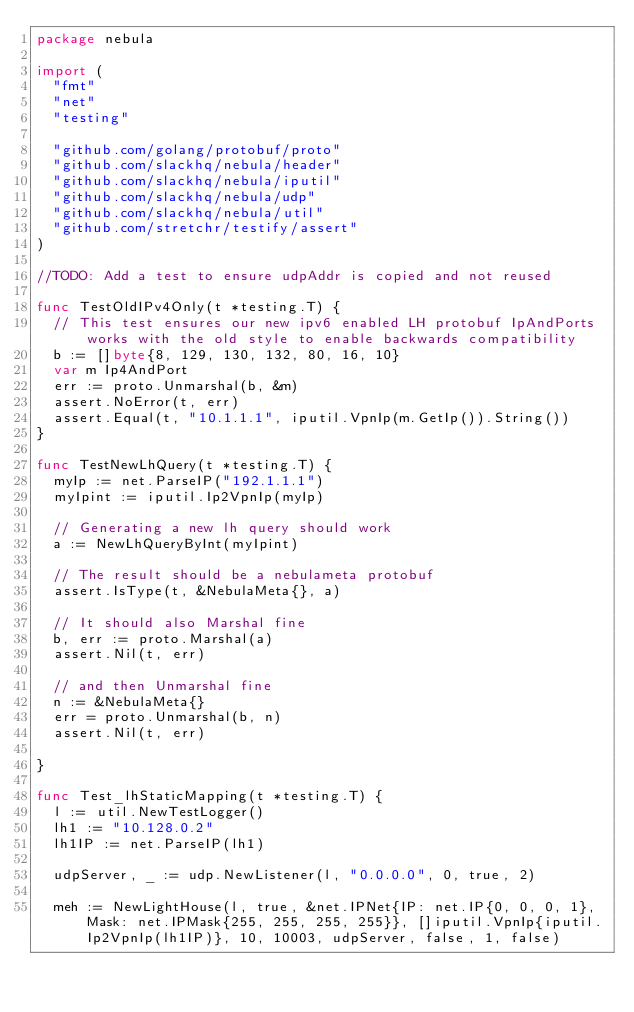Convert code to text. <code><loc_0><loc_0><loc_500><loc_500><_Go_>package nebula

import (
	"fmt"
	"net"
	"testing"

	"github.com/golang/protobuf/proto"
	"github.com/slackhq/nebula/header"
	"github.com/slackhq/nebula/iputil"
	"github.com/slackhq/nebula/udp"
	"github.com/slackhq/nebula/util"
	"github.com/stretchr/testify/assert"
)

//TODO: Add a test to ensure udpAddr is copied and not reused

func TestOldIPv4Only(t *testing.T) {
	// This test ensures our new ipv6 enabled LH protobuf IpAndPorts works with the old style to enable backwards compatibility
	b := []byte{8, 129, 130, 132, 80, 16, 10}
	var m Ip4AndPort
	err := proto.Unmarshal(b, &m)
	assert.NoError(t, err)
	assert.Equal(t, "10.1.1.1", iputil.VpnIp(m.GetIp()).String())
}

func TestNewLhQuery(t *testing.T) {
	myIp := net.ParseIP("192.1.1.1")
	myIpint := iputil.Ip2VpnIp(myIp)

	// Generating a new lh query should work
	a := NewLhQueryByInt(myIpint)

	// The result should be a nebulameta protobuf
	assert.IsType(t, &NebulaMeta{}, a)

	// It should also Marshal fine
	b, err := proto.Marshal(a)
	assert.Nil(t, err)

	// and then Unmarshal fine
	n := &NebulaMeta{}
	err = proto.Unmarshal(b, n)
	assert.Nil(t, err)

}

func Test_lhStaticMapping(t *testing.T) {
	l := util.NewTestLogger()
	lh1 := "10.128.0.2"
	lh1IP := net.ParseIP(lh1)

	udpServer, _ := udp.NewListener(l, "0.0.0.0", 0, true, 2)

	meh := NewLightHouse(l, true, &net.IPNet{IP: net.IP{0, 0, 0, 1}, Mask: net.IPMask{255, 255, 255, 255}}, []iputil.VpnIp{iputil.Ip2VpnIp(lh1IP)}, 10, 10003, udpServer, false, 1, false)</code> 